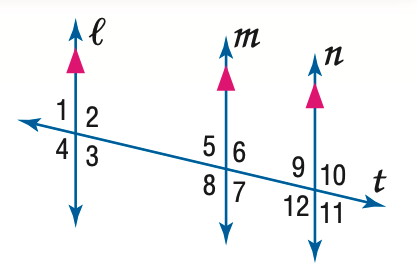Answer the mathemtical geometry problem and directly provide the correct option letter.
Question: In the figure, m \angle 9 = 75. Find the measure of \angle 5.
Choices: A: 75 B: 85 C: 95 D: 105 A 